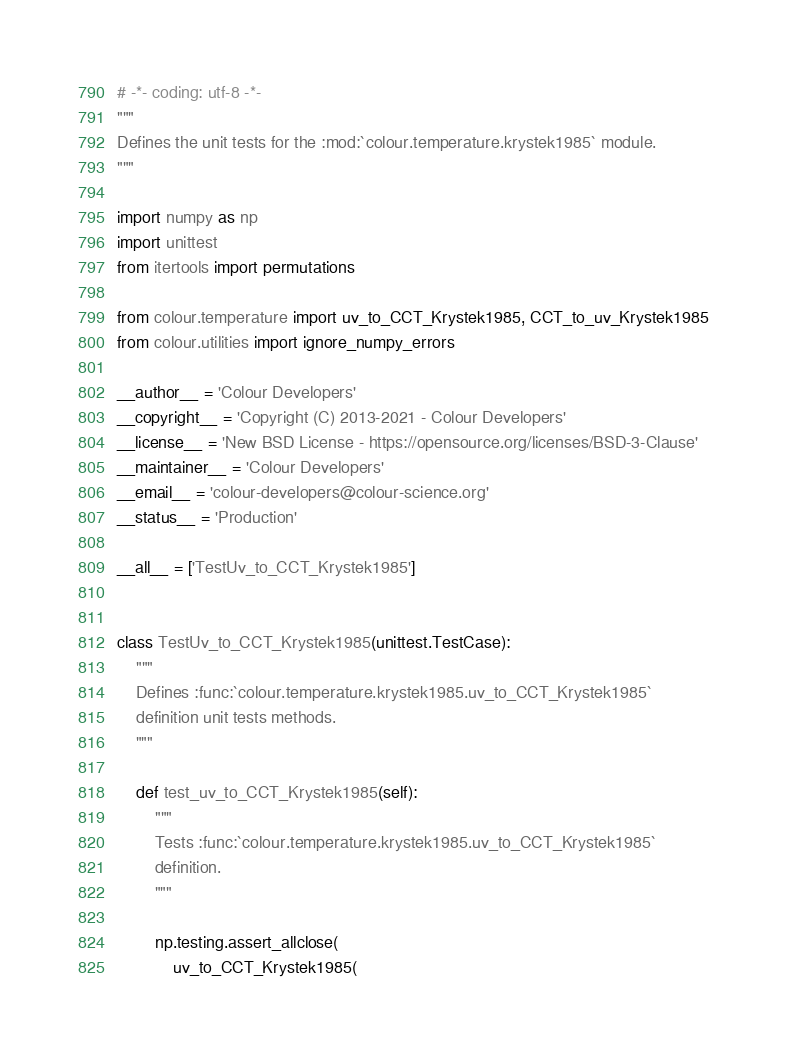<code> <loc_0><loc_0><loc_500><loc_500><_Python_># -*- coding: utf-8 -*-
"""
Defines the unit tests for the :mod:`colour.temperature.krystek1985` module.
"""

import numpy as np
import unittest
from itertools import permutations

from colour.temperature import uv_to_CCT_Krystek1985, CCT_to_uv_Krystek1985
from colour.utilities import ignore_numpy_errors

__author__ = 'Colour Developers'
__copyright__ = 'Copyright (C) 2013-2021 - Colour Developers'
__license__ = 'New BSD License - https://opensource.org/licenses/BSD-3-Clause'
__maintainer__ = 'Colour Developers'
__email__ = 'colour-developers@colour-science.org'
__status__ = 'Production'

__all__ = ['TestUv_to_CCT_Krystek1985']


class TestUv_to_CCT_Krystek1985(unittest.TestCase):
    """
    Defines :func:`colour.temperature.krystek1985.uv_to_CCT_Krystek1985`
    definition unit tests methods.
    """

    def test_uv_to_CCT_Krystek1985(self):
        """
        Tests :func:`colour.temperature.krystek1985.uv_to_CCT_Krystek1985`
        definition.
        """

        np.testing.assert_allclose(
            uv_to_CCT_Krystek1985(</code> 